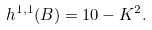Convert formula to latex. <formula><loc_0><loc_0><loc_500><loc_500>h ^ { 1 , 1 } ( B ) = 1 0 - K ^ { 2 } .</formula> 